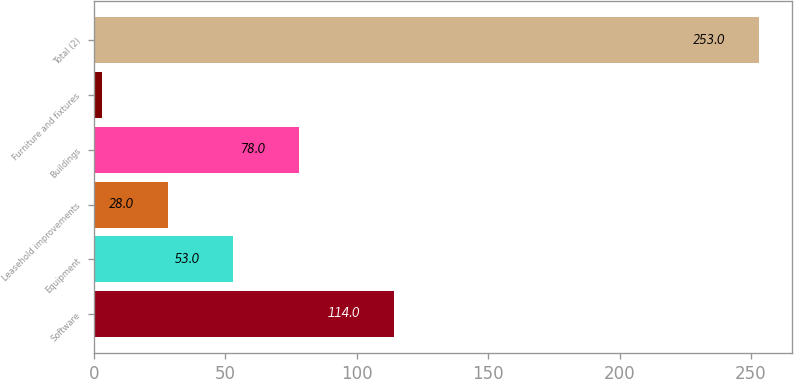Convert chart. <chart><loc_0><loc_0><loc_500><loc_500><bar_chart><fcel>Software<fcel>Equipment<fcel>Leasehold improvements<fcel>Buildings<fcel>Furniture and fixtures<fcel>Total (2)<nl><fcel>114<fcel>53<fcel>28<fcel>78<fcel>3<fcel>253<nl></chart> 